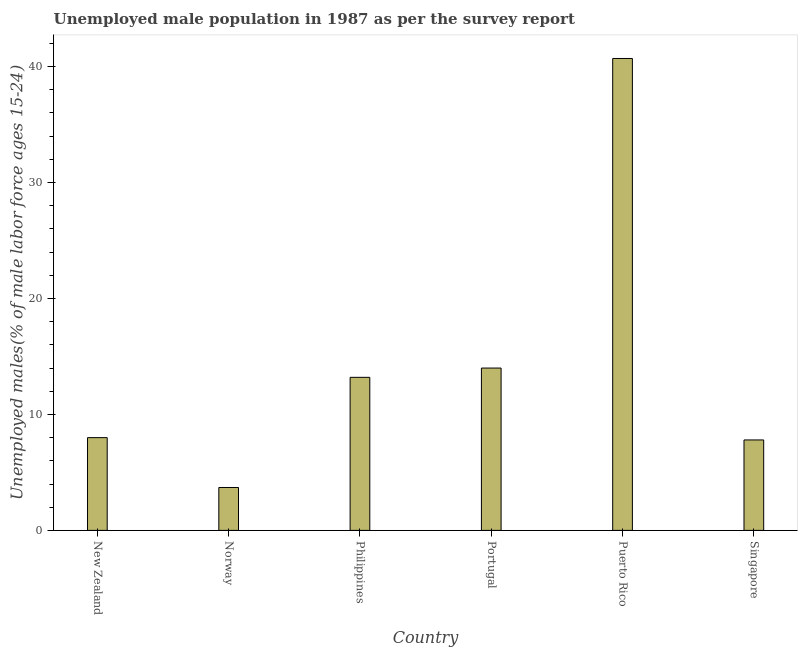Does the graph contain grids?
Make the answer very short. No. What is the title of the graph?
Offer a terse response. Unemployed male population in 1987 as per the survey report. What is the label or title of the X-axis?
Ensure brevity in your answer.  Country. What is the label or title of the Y-axis?
Your answer should be very brief. Unemployed males(% of male labor force ages 15-24). What is the unemployed male youth in Portugal?
Your answer should be compact. 14. Across all countries, what is the maximum unemployed male youth?
Your answer should be compact. 40.7. Across all countries, what is the minimum unemployed male youth?
Give a very brief answer. 3.7. In which country was the unemployed male youth maximum?
Make the answer very short. Puerto Rico. In which country was the unemployed male youth minimum?
Provide a succinct answer. Norway. What is the sum of the unemployed male youth?
Offer a terse response. 87.4. What is the difference between the unemployed male youth in Philippines and Puerto Rico?
Ensure brevity in your answer.  -27.5. What is the average unemployed male youth per country?
Offer a very short reply. 14.57. What is the median unemployed male youth?
Offer a terse response. 10.6. What is the ratio of the unemployed male youth in New Zealand to that in Norway?
Your answer should be very brief. 2.16. Is the unemployed male youth in New Zealand less than that in Singapore?
Give a very brief answer. No. Is the difference between the unemployed male youth in New Zealand and Philippines greater than the difference between any two countries?
Your answer should be very brief. No. What is the difference between the highest and the second highest unemployed male youth?
Provide a short and direct response. 26.7. Is the sum of the unemployed male youth in Philippines and Puerto Rico greater than the maximum unemployed male youth across all countries?
Your response must be concise. Yes. How many countries are there in the graph?
Provide a short and direct response. 6. Are the values on the major ticks of Y-axis written in scientific E-notation?
Offer a terse response. No. What is the Unemployed males(% of male labor force ages 15-24) of Norway?
Keep it short and to the point. 3.7. What is the Unemployed males(% of male labor force ages 15-24) in Philippines?
Your answer should be very brief. 13.2. What is the Unemployed males(% of male labor force ages 15-24) of Puerto Rico?
Give a very brief answer. 40.7. What is the Unemployed males(% of male labor force ages 15-24) of Singapore?
Provide a short and direct response. 7.8. What is the difference between the Unemployed males(% of male labor force ages 15-24) in New Zealand and Portugal?
Your answer should be very brief. -6. What is the difference between the Unemployed males(% of male labor force ages 15-24) in New Zealand and Puerto Rico?
Offer a very short reply. -32.7. What is the difference between the Unemployed males(% of male labor force ages 15-24) in New Zealand and Singapore?
Give a very brief answer. 0.2. What is the difference between the Unemployed males(% of male labor force ages 15-24) in Norway and Puerto Rico?
Keep it short and to the point. -37. What is the difference between the Unemployed males(% of male labor force ages 15-24) in Norway and Singapore?
Make the answer very short. -4.1. What is the difference between the Unemployed males(% of male labor force ages 15-24) in Philippines and Puerto Rico?
Offer a terse response. -27.5. What is the difference between the Unemployed males(% of male labor force ages 15-24) in Portugal and Puerto Rico?
Offer a very short reply. -26.7. What is the difference between the Unemployed males(% of male labor force ages 15-24) in Portugal and Singapore?
Keep it short and to the point. 6.2. What is the difference between the Unemployed males(% of male labor force ages 15-24) in Puerto Rico and Singapore?
Ensure brevity in your answer.  32.9. What is the ratio of the Unemployed males(% of male labor force ages 15-24) in New Zealand to that in Norway?
Your response must be concise. 2.16. What is the ratio of the Unemployed males(% of male labor force ages 15-24) in New Zealand to that in Philippines?
Your answer should be very brief. 0.61. What is the ratio of the Unemployed males(% of male labor force ages 15-24) in New Zealand to that in Portugal?
Keep it short and to the point. 0.57. What is the ratio of the Unemployed males(% of male labor force ages 15-24) in New Zealand to that in Puerto Rico?
Your answer should be compact. 0.2. What is the ratio of the Unemployed males(% of male labor force ages 15-24) in Norway to that in Philippines?
Keep it short and to the point. 0.28. What is the ratio of the Unemployed males(% of male labor force ages 15-24) in Norway to that in Portugal?
Your answer should be compact. 0.26. What is the ratio of the Unemployed males(% of male labor force ages 15-24) in Norway to that in Puerto Rico?
Provide a succinct answer. 0.09. What is the ratio of the Unemployed males(% of male labor force ages 15-24) in Norway to that in Singapore?
Offer a terse response. 0.47. What is the ratio of the Unemployed males(% of male labor force ages 15-24) in Philippines to that in Portugal?
Ensure brevity in your answer.  0.94. What is the ratio of the Unemployed males(% of male labor force ages 15-24) in Philippines to that in Puerto Rico?
Give a very brief answer. 0.32. What is the ratio of the Unemployed males(% of male labor force ages 15-24) in Philippines to that in Singapore?
Keep it short and to the point. 1.69. What is the ratio of the Unemployed males(% of male labor force ages 15-24) in Portugal to that in Puerto Rico?
Your answer should be compact. 0.34. What is the ratio of the Unemployed males(% of male labor force ages 15-24) in Portugal to that in Singapore?
Provide a succinct answer. 1.79. What is the ratio of the Unemployed males(% of male labor force ages 15-24) in Puerto Rico to that in Singapore?
Ensure brevity in your answer.  5.22. 